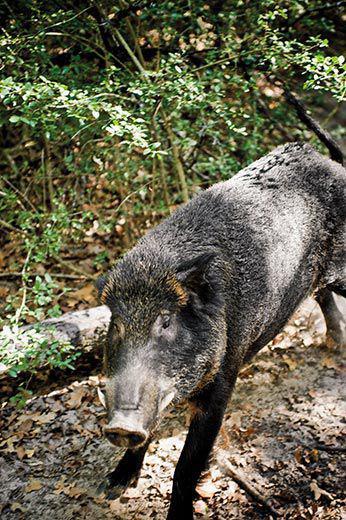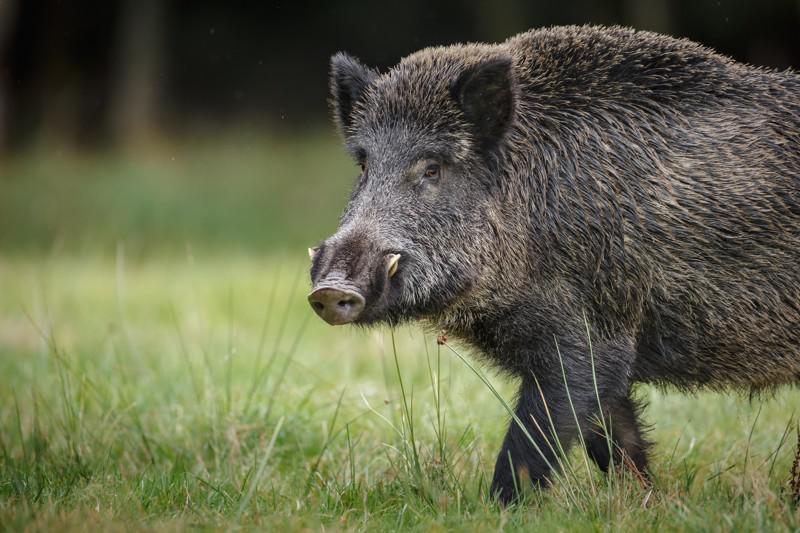The first image is the image on the left, the second image is the image on the right. Analyze the images presented: Is the assertion "An image contains a single boar wading through water." valid? Answer yes or no. No. The first image is the image on the left, the second image is the image on the right. Assess this claim about the two images: "One image shows a wild pig wading in brown water". Correct or not? Answer yes or no. No. 